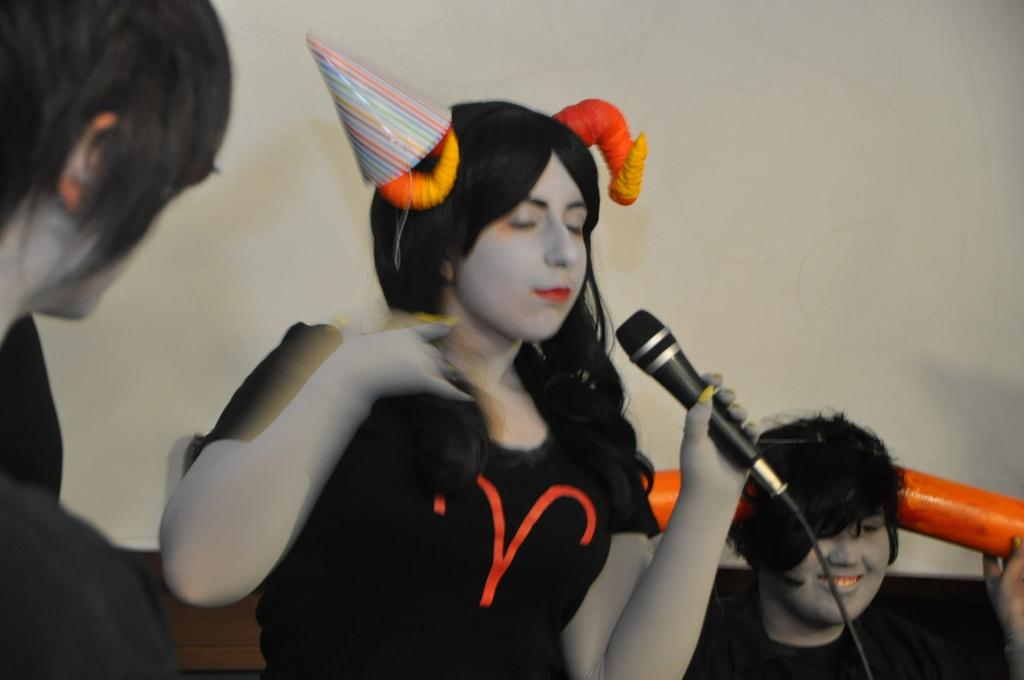How many people are present in the image? There are three people in the image. What is the woman holding in her hand? The woman is holding a microphone in her hand. Can you describe the woman's attire? The woman is wearing a cap. What type of wrench is the woman using to fix the church's border in the image? There is no wrench, church, or border present in the image. 